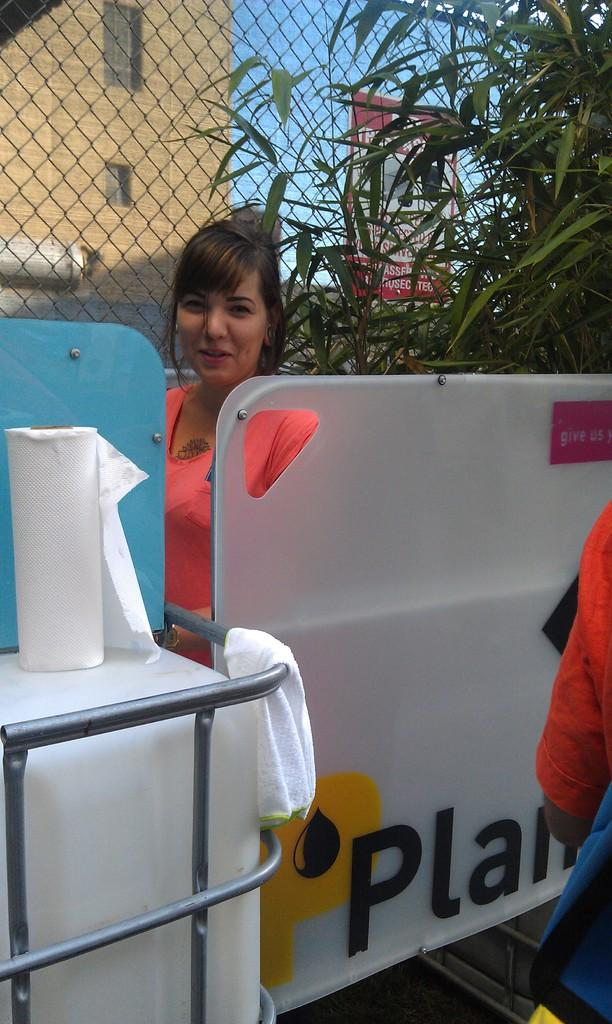What is the main subject of the image? There is a woman standing in the image. What is the woman standing on? The woman is standing on the floor. What object can be seen near the woman? There is a tissue holder in the image. What type of material is present in the image? There is a mesh in the image. What type of vegetation is visible in the image? There are trees in the image. What type of sign is present in the image? There is an advertisement board in the image. What type of structure is visible in the image? There is a building in the image. What part of the natural environment is visible in the image? The sky is visible in the image. What type of pickle is being used as a hat by the person in the image? There is no person wearing a pickle as a hat in the image. What shape is the circle that the person is holding in the image? There is no person holding a circle in the image. 